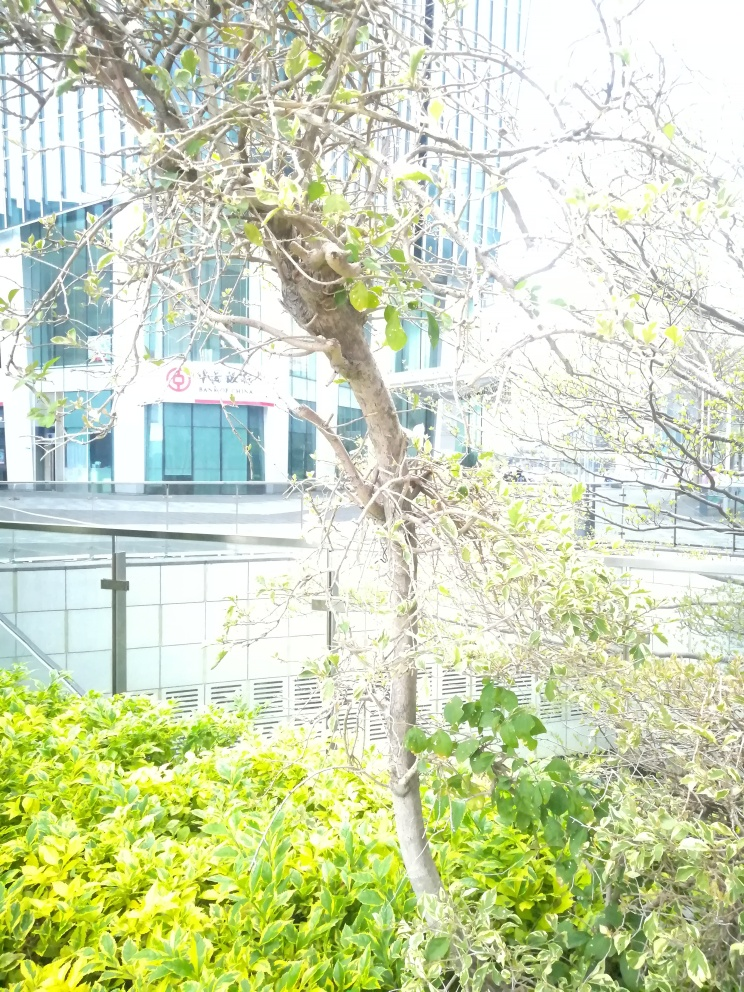What is the significance of the tree in the foreground? The tree in the foreground provides a natural element that contrasts with the urban environment. It may signify the integration of green spaces within built-up areas and suggests an effort to create a more sustainable and pleasant urban landscape. 